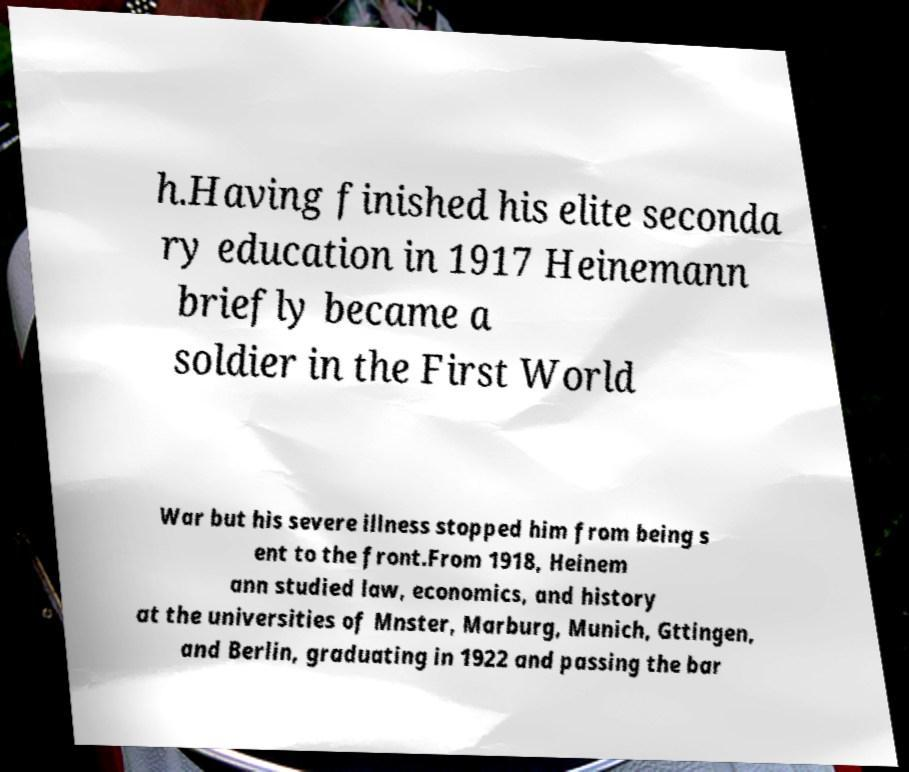I need the written content from this picture converted into text. Can you do that? h.Having finished his elite seconda ry education in 1917 Heinemann briefly became a soldier in the First World War but his severe illness stopped him from being s ent to the front.From 1918, Heinem ann studied law, economics, and history at the universities of Mnster, Marburg, Munich, Gttingen, and Berlin, graduating in 1922 and passing the bar 